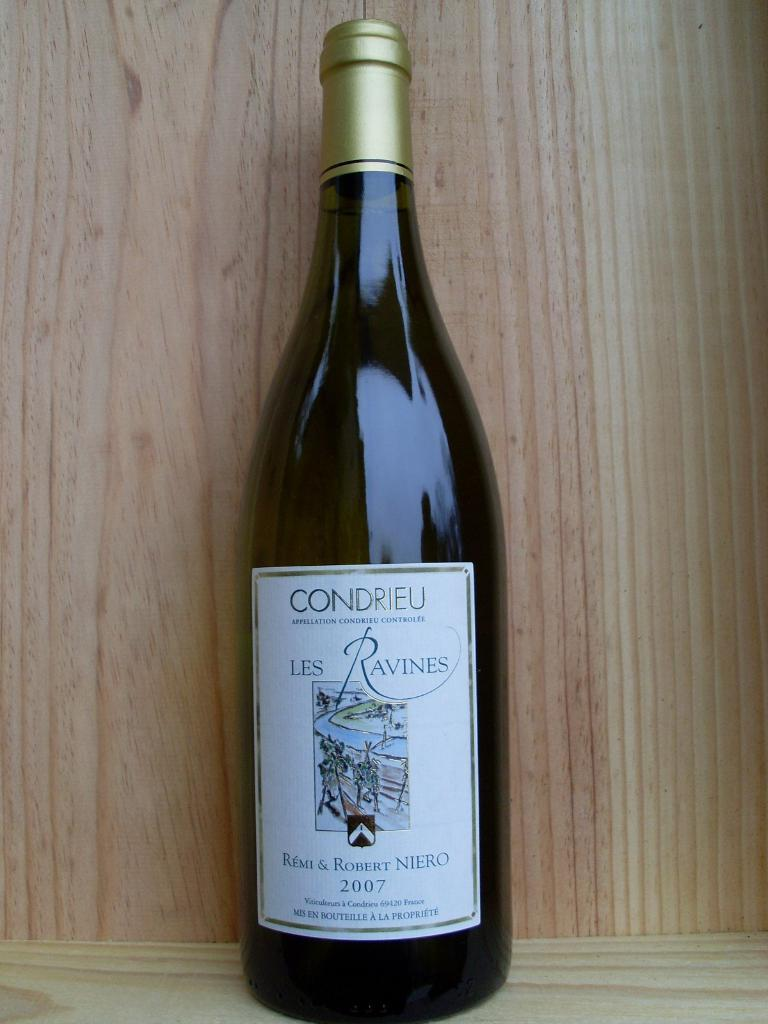<image>
Describe the image concisely. An unopened bottle of Condrieu Les Ravines from 2007. 